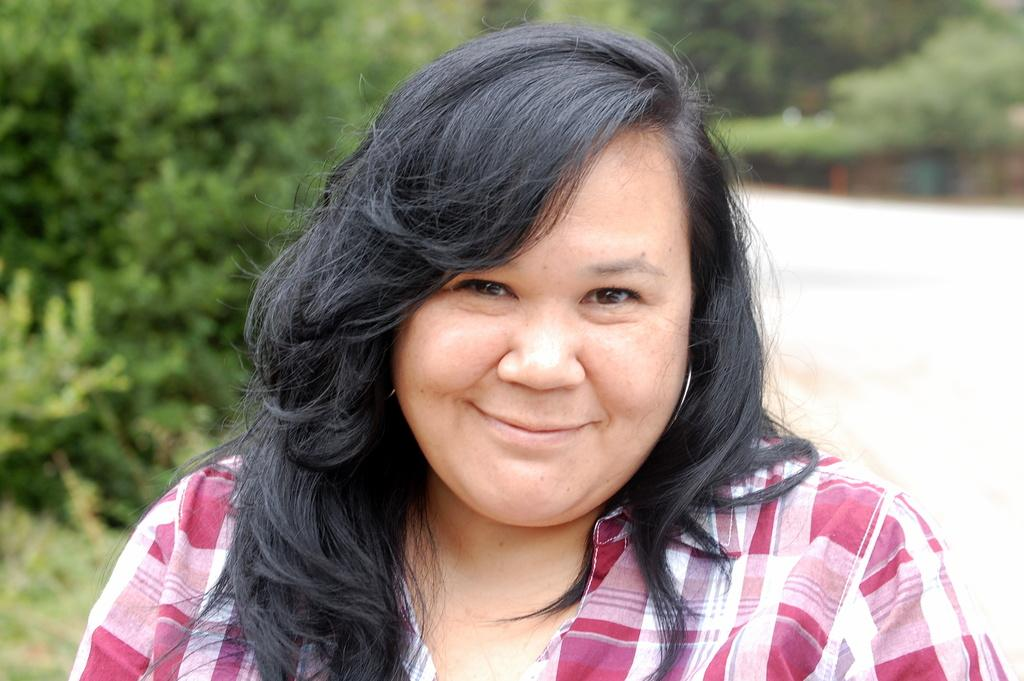Who is present in the image? There is a woman in the image. What is the woman's facial expression? The woman is smiling. What can be seen in the background of the image? There are trees in the background of the image. What type of ship can be seen in the background of the image? There is no ship present in the image; it only features a woman and trees in the background. 